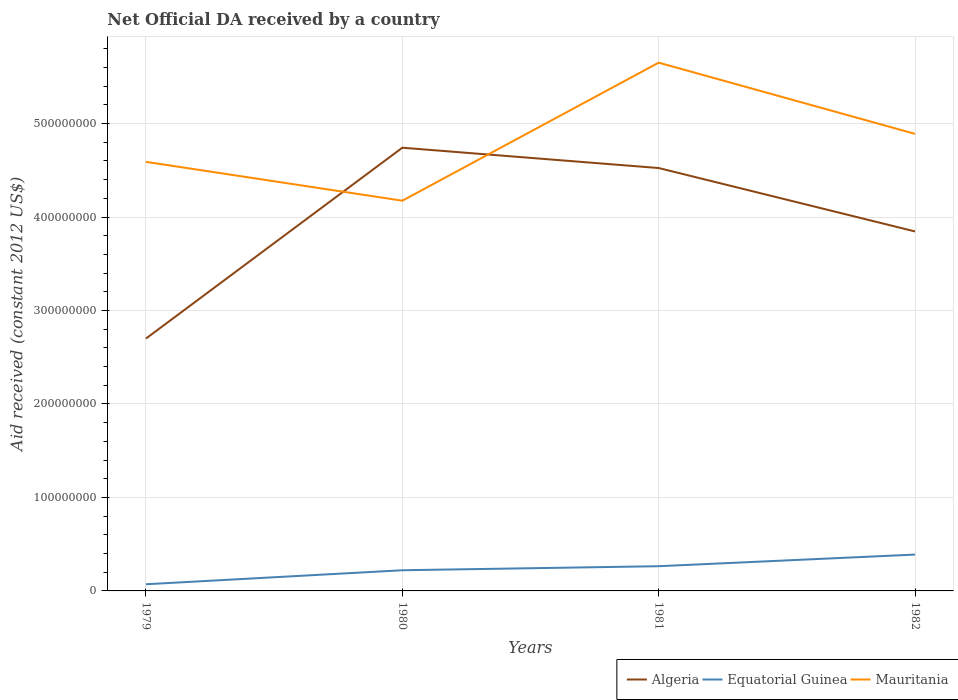How many different coloured lines are there?
Provide a short and direct response. 3. Does the line corresponding to Algeria intersect with the line corresponding to Mauritania?
Your answer should be very brief. Yes. Is the number of lines equal to the number of legend labels?
Offer a terse response. Yes. Across all years, what is the maximum net official development assistance aid received in Mauritania?
Your answer should be compact. 4.17e+08. In which year was the net official development assistance aid received in Equatorial Guinea maximum?
Your answer should be compact. 1979. What is the total net official development assistance aid received in Equatorial Guinea in the graph?
Offer a terse response. -4.32e+06. What is the difference between the highest and the second highest net official development assistance aid received in Mauritania?
Provide a succinct answer. 1.48e+08. Where does the legend appear in the graph?
Ensure brevity in your answer.  Bottom right. How many legend labels are there?
Provide a short and direct response. 3. How are the legend labels stacked?
Your answer should be compact. Horizontal. What is the title of the graph?
Your answer should be very brief. Net Official DA received by a country. Does "Latvia" appear as one of the legend labels in the graph?
Offer a very short reply. No. What is the label or title of the X-axis?
Make the answer very short. Years. What is the label or title of the Y-axis?
Your answer should be very brief. Aid received (constant 2012 US$). What is the Aid received (constant 2012 US$) in Algeria in 1979?
Ensure brevity in your answer.  2.70e+08. What is the Aid received (constant 2012 US$) in Equatorial Guinea in 1979?
Offer a terse response. 7.13e+06. What is the Aid received (constant 2012 US$) of Mauritania in 1979?
Your response must be concise. 4.59e+08. What is the Aid received (constant 2012 US$) in Algeria in 1980?
Provide a succinct answer. 4.74e+08. What is the Aid received (constant 2012 US$) of Equatorial Guinea in 1980?
Offer a very short reply. 2.21e+07. What is the Aid received (constant 2012 US$) in Mauritania in 1980?
Ensure brevity in your answer.  4.17e+08. What is the Aid received (constant 2012 US$) of Algeria in 1981?
Keep it short and to the point. 4.52e+08. What is the Aid received (constant 2012 US$) of Equatorial Guinea in 1981?
Ensure brevity in your answer.  2.64e+07. What is the Aid received (constant 2012 US$) in Mauritania in 1981?
Offer a very short reply. 5.65e+08. What is the Aid received (constant 2012 US$) in Algeria in 1982?
Offer a terse response. 3.85e+08. What is the Aid received (constant 2012 US$) in Equatorial Guinea in 1982?
Your answer should be very brief. 3.89e+07. What is the Aid received (constant 2012 US$) of Mauritania in 1982?
Keep it short and to the point. 4.89e+08. Across all years, what is the maximum Aid received (constant 2012 US$) of Algeria?
Provide a short and direct response. 4.74e+08. Across all years, what is the maximum Aid received (constant 2012 US$) in Equatorial Guinea?
Make the answer very short. 3.89e+07. Across all years, what is the maximum Aid received (constant 2012 US$) in Mauritania?
Make the answer very short. 5.65e+08. Across all years, what is the minimum Aid received (constant 2012 US$) in Algeria?
Your answer should be compact. 2.70e+08. Across all years, what is the minimum Aid received (constant 2012 US$) in Equatorial Guinea?
Your response must be concise. 7.13e+06. Across all years, what is the minimum Aid received (constant 2012 US$) of Mauritania?
Provide a short and direct response. 4.17e+08. What is the total Aid received (constant 2012 US$) in Algeria in the graph?
Your answer should be very brief. 1.58e+09. What is the total Aid received (constant 2012 US$) in Equatorial Guinea in the graph?
Make the answer very short. 9.46e+07. What is the total Aid received (constant 2012 US$) in Mauritania in the graph?
Your answer should be very brief. 1.93e+09. What is the difference between the Aid received (constant 2012 US$) of Algeria in 1979 and that in 1980?
Ensure brevity in your answer.  -2.04e+08. What is the difference between the Aid received (constant 2012 US$) of Equatorial Guinea in 1979 and that in 1980?
Your response must be concise. -1.50e+07. What is the difference between the Aid received (constant 2012 US$) in Mauritania in 1979 and that in 1980?
Offer a terse response. 4.16e+07. What is the difference between the Aid received (constant 2012 US$) in Algeria in 1979 and that in 1981?
Provide a short and direct response. -1.82e+08. What is the difference between the Aid received (constant 2012 US$) of Equatorial Guinea in 1979 and that in 1981?
Keep it short and to the point. -1.93e+07. What is the difference between the Aid received (constant 2012 US$) in Mauritania in 1979 and that in 1981?
Ensure brevity in your answer.  -1.06e+08. What is the difference between the Aid received (constant 2012 US$) in Algeria in 1979 and that in 1982?
Provide a short and direct response. -1.15e+08. What is the difference between the Aid received (constant 2012 US$) of Equatorial Guinea in 1979 and that in 1982?
Offer a very short reply. -3.18e+07. What is the difference between the Aid received (constant 2012 US$) of Mauritania in 1979 and that in 1982?
Your answer should be very brief. -2.99e+07. What is the difference between the Aid received (constant 2012 US$) in Algeria in 1980 and that in 1981?
Provide a short and direct response. 2.17e+07. What is the difference between the Aid received (constant 2012 US$) in Equatorial Guinea in 1980 and that in 1981?
Offer a very short reply. -4.32e+06. What is the difference between the Aid received (constant 2012 US$) of Mauritania in 1980 and that in 1981?
Provide a short and direct response. -1.48e+08. What is the difference between the Aid received (constant 2012 US$) in Algeria in 1980 and that in 1982?
Your answer should be compact. 8.96e+07. What is the difference between the Aid received (constant 2012 US$) of Equatorial Guinea in 1980 and that in 1982?
Ensure brevity in your answer.  -1.68e+07. What is the difference between the Aid received (constant 2012 US$) of Mauritania in 1980 and that in 1982?
Offer a terse response. -7.15e+07. What is the difference between the Aid received (constant 2012 US$) in Algeria in 1981 and that in 1982?
Offer a very short reply. 6.78e+07. What is the difference between the Aid received (constant 2012 US$) in Equatorial Guinea in 1981 and that in 1982?
Provide a short and direct response. -1.24e+07. What is the difference between the Aid received (constant 2012 US$) of Mauritania in 1981 and that in 1982?
Your answer should be compact. 7.62e+07. What is the difference between the Aid received (constant 2012 US$) in Algeria in 1979 and the Aid received (constant 2012 US$) in Equatorial Guinea in 1980?
Make the answer very short. 2.48e+08. What is the difference between the Aid received (constant 2012 US$) of Algeria in 1979 and the Aid received (constant 2012 US$) of Mauritania in 1980?
Offer a very short reply. -1.48e+08. What is the difference between the Aid received (constant 2012 US$) in Equatorial Guinea in 1979 and the Aid received (constant 2012 US$) in Mauritania in 1980?
Your answer should be compact. -4.10e+08. What is the difference between the Aid received (constant 2012 US$) in Algeria in 1979 and the Aid received (constant 2012 US$) in Equatorial Guinea in 1981?
Your answer should be compact. 2.44e+08. What is the difference between the Aid received (constant 2012 US$) of Algeria in 1979 and the Aid received (constant 2012 US$) of Mauritania in 1981?
Provide a short and direct response. -2.95e+08. What is the difference between the Aid received (constant 2012 US$) in Equatorial Guinea in 1979 and the Aid received (constant 2012 US$) in Mauritania in 1981?
Provide a short and direct response. -5.58e+08. What is the difference between the Aid received (constant 2012 US$) in Algeria in 1979 and the Aid received (constant 2012 US$) in Equatorial Guinea in 1982?
Keep it short and to the point. 2.31e+08. What is the difference between the Aid received (constant 2012 US$) in Algeria in 1979 and the Aid received (constant 2012 US$) in Mauritania in 1982?
Provide a short and direct response. -2.19e+08. What is the difference between the Aid received (constant 2012 US$) of Equatorial Guinea in 1979 and the Aid received (constant 2012 US$) of Mauritania in 1982?
Offer a terse response. -4.82e+08. What is the difference between the Aid received (constant 2012 US$) in Algeria in 1980 and the Aid received (constant 2012 US$) in Equatorial Guinea in 1981?
Your response must be concise. 4.48e+08. What is the difference between the Aid received (constant 2012 US$) of Algeria in 1980 and the Aid received (constant 2012 US$) of Mauritania in 1981?
Ensure brevity in your answer.  -9.10e+07. What is the difference between the Aid received (constant 2012 US$) in Equatorial Guinea in 1980 and the Aid received (constant 2012 US$) in Mauritania in 1981?
Ensure brevity in your answer.  -5.43e+08. What is the difference between the Aid received (constant 2012 US$) of Algeria in 1980 and the Aid received (constant 2012 US$) of Equatorial Guinea in 1982?
Make the answer very short. 4.35e+08. What is the difference between the Aid received (constant 2012 US$) in Algeria in 1980 and the Aid received (constant 2012 US$) in Mauritania in 1982?
Your response must be concise. -1.48e+07. What is the difference between the Aid received (constant 2012 US$) in Equatorial Guinea in 1980 and the Aid received (constant 2012 US$) in Mauritania in 1982?
Make the answer very short. -4.67e+08. What is the difference between the Aid received (constant 2012 US$) in Algeria in 1981 and the Aid received (constant 2012 US$) in Equatorial Guinea in 1982?
Your answer should be very brief. 4.14e+08. What is the difference between the Aid received (constant 2012 US$) of Algeria in 1981 and the Aid received (constant 2012 US$) of Mauritania in 1982?
Ensure brevity in your answer.  -3.65e+07. What is the difference between the Aid received (constant 2012 US$) of Equatorial Guinea in 1981 and the Aid received (constant 2012 US$) of Mauritania in 1982?
Ensure brevity in your answer.  -4.63e+08. What is the average Aid received (constant 2012 US$) in Algeria per year?
Your answer should be very brief. 3.95e+08. What is the average Aid received (constant 2012 US$) of Equatorial Guinea per year?
Keep it short and to the point. 2.36e+07. What is the average Aid received (constant 2012 US$) in Mauritania per year?
Give a very brief answer. 4.83e+08. In the year 1979, what is the difference between the Aid received (constant 2012 US$) in Algeria and Aid received (constant 2012 US$) in Equatorial Guinea?
Your response must be concise. 2.63e+08. In the year 1979, what is the difference between the Aid received (constant 2012 US$) in Algeria and Aid received (constant 2012 US$) in Mauritania?
Ensure brevity in your answer.  -1.89e+08. In the year 1979, what is the difference between the Aid received (constant 2012 US$) in Equatorial Guinea and Aid received (constant 2012 US$) in Mauritania?
Keep it short and to the point. -4.52e+08. In the year 1980, what is the difference between the Aid received (constant 2012 US$) in Algeria and Aid received (constant 2012 US$) in Equatorial Guinea?
Your answer should be compact. 4.52e+08. In the year 1980, what is the difference between the Aid received (constant 2012 US$) in Algeria and Aid received (constant 2012 US$) in Mauritania?
Your response must be concise. 5.67e+07. In the year 1980, what is the difference between the Aid received (constant 2012 US$) of Equatorial Guinea and Aid received (constant 2012 US$) of Mauritania?
Offer a very short reply. -3.95e+08. In the year 1981, what is the difference between the Aid received (constant 2012 US$) in Algeria and Aid received (constant 2012 US$) in Equatorial Guinea?
Your answer should be very brief. 4.26e+08. In the year 1981, what is the difference between the Aid received (constant 2012 US$) in Algeria and Aid received (constant 2012 US$) in Mauritania?
Offer a very short reply. -1.13e+08. In the year 1981, what is the difference between the Aid received (constant 2012 US$) of Equatorial Guinea and Aid received (constant 2012 US$) of Mauritania?
Keep it short and to the point. -5.39e+08. In the year 1982, what is the difference between the Aid received (constant 2012 US$) in Algeria and Aid received (constant 2012 US$) in Equatorial Guinea?
Your answer should be compact. 3.46e+08. In the year 1982, what is the difference between the Aid received (constant 2012 US$) of Algeria and Aid received (constant 2012 US$) of Mauritania?
Your answer should be very brief. -1.04e+08. In the year 1982, what is the difference between the Aid received (constant 2012 US$) in Equatorial Guinea and Aid received (constant 2012 US$) in Mauritania?
Provide a short and direct response. -4.50e+08. What is the ratio of the Aid received (constant 2012 US$) of Algeria in 1979 to that in 1980?
Provide a short and direct response. 0.57. What is the ratio of the Aid received (constant 2012 US$) in Equatorial Guinea in 1979 to that in 1980?
Make the answer very short. 0.32. What is the ratio of the Aid received (constant 2012 US$) of Mauritania in 1979 to that in 1980?
Your response must be concise. 1.1. What is the ratio of the Aid received (constant 2012 US$) in Algeria in 1979 to that in 1981?
Your response must be concise. 0.6. What is the ratio of the Aid received (constant 2012 US$) of Equatorial Guinea in 1979 to that in 1981?
Keep it short and to the point. 0.27. What is the ratio of the Aid received (constant 2012 US$) in Mauritania in 1979 to that in 1981?
Provide a succinct answer. 0.81. What is the ratio of the Aid received (constant 2012 US$) of Algeria in 1979 to that in 1982?
Offer a very short reply. 0.7. What is the ratio of the Aid received (constant 2012 US$) in Equatorial Guinea in 1979 to that in 1982?
Your response must be concise. 0.18. What is the ratio of the Aid received (constant 2012 US$) in Mauritania in 1979 to that in 1982?
Offer a terse response. 0.94. What is the ratio of the Aid received (constant 2012 US$) of Algeria in 1980 to that in 1981?
Offer a very short reply. 1.05. What is the ratio of the Aid received (constant 2012 US$) in Equatorial Guinea in 1980 to that in 1981?
Your response must be concise. 0.84. What is the ratio of the Aid received (constant 2012 US$) in Mauritania in 1980 to that in 1981?
Provide a succinct answer. 0.74. What is the ratio of the Aid received (constant 2012 US$) of Algeria in 1980 to that in 1982?
Your answer should be very brief. 1.23. What is the ratio of the Aid received (constant 2012 US$) in Equatorial Guinea in 1980 to that in 1982?
Your response must be concise. 0.57. What is the ratio of the Aid received (constant 2012 US$) of Mauritania in 1980 to that in 1982?
Offer a very short reply. 0.85. What is the ratio of the Aid received (constant 2012 US$) of Algeria in 1981 to that in 1982?
Offer a very short reply. 1.18. What is the ratio of the Aid received (constant 2012 US$) in Equatorial Guinea in 1981 to that in 1982?
Offer a very short reply. 0.68. What is the ratio of the Aid received (constant 2012 US$) of Mauritania in 1981 to that in 1982?
Provide a short and direct response. 1.16. What is the difference between the highest and the second highest Aid received (constant 2012 US$) of Algeria?
Offer a terse response. 2.17e+07. What is the difference between the highest and the second highest Aid received (constant 2012 US$) in Equatorial Guinea?
Provide a succinct answer. 1.24e+07. What is the difference between the highest and the second highest Aid received (constant 2012 US$) in Mauritania?
Make the answer very short. 7.62e+07. What is the difference between the highest and the lowest Aid received (constant 2012 US$) of Algeria?
Make the answer very short. 2.04e+08. What is the difference between the highest and the lowest Aid received (constant 2012 US$) of Equatorial Guinea?
Ensure brevity in your answer.  3.18e+07. What is the difference between the highest and the lowest Aid received (constant 2012 US$) of Mauritania?
Your answer should be compact. 1.48e+08. 